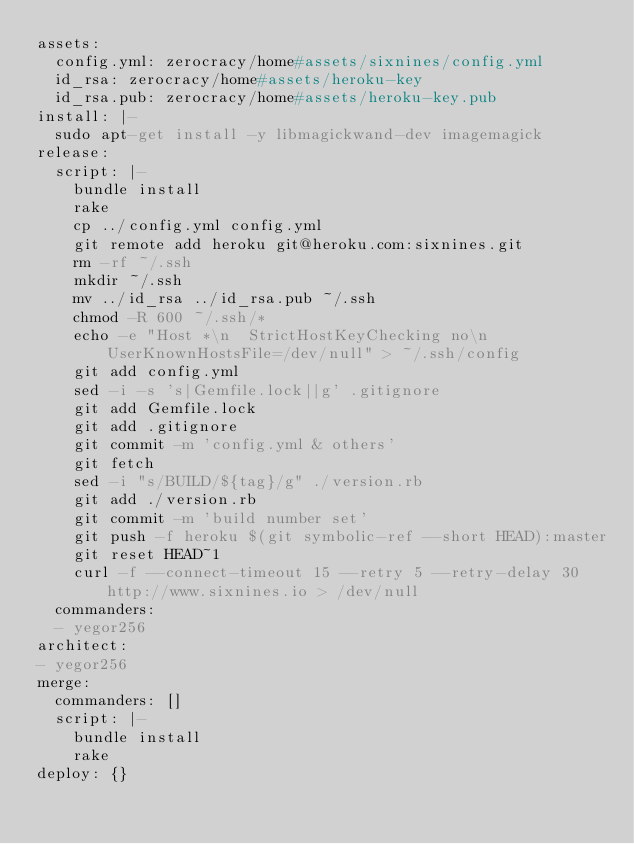<code> <loc_0><loc_0><loc_500><loc_500><_YAML_>assets:
  config.yml: zerocracy/home#assets/sixnines/config.yml
  id_rsa: zerocracy/home#assets/heroku-key
  id_rsa.pub: zerocracy/home#assets/heroku-key.pub
install: |-
  sudo apt-get install -y libmagickwand-dev imagemagick
release:
  script: |-
    bundle install
    rake
    cp ../config.yml config.yml
    git remote add heroku git@heroku.com:sixnines.git
    rm -rf ~/.ssh
    mkdir ~/.ssh
    mv ../id_rsa ../id_rsa.pub ~/.ssh
    chmod -R 600 ~/.ssh/*
    echo -e "Host *\n  StrictHostKeyChecking no\n  UserKnownHostsFile=/dev/null" > ~/.ssh/config
    git add config.yml
    sed -i -s 's|Gemfile.lock||g' .gitignore
    git add Gemfile.lock
    git add .gitignore
    git commit -m 'config.yml & others'
    git fetch
    sed -i "s/BUILD/${tag}/g" ./version.rb
    git add ./version.rb
    git commit -m 'build number set'
    git push -f heroku $(git symbolic-ref --short HEAD):master
    git reset HEAD~1
    curl -f --connect-timeout 15 --retry 5 --retry-delay 30 http://www.sixnines.io > /dev/null
  commanders:
  - yegor256
architect:
- yegor256
merge:
  commanders: []
  script: |-
    bundle install
    rake
deploy: {}
</code> 